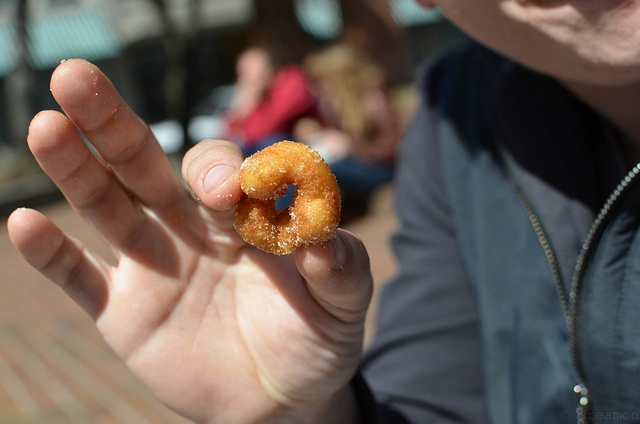Describe the objects in this image and their specific colors. I can see people in teal, gray, black, brown, and tan tones, donut in teal, brown, orange, and maroon tones, and people in teal, brown, tan, and maroon tones in this image. 